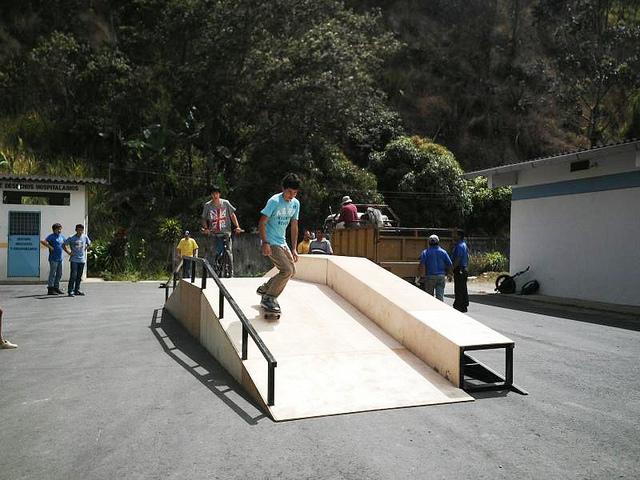What is the boy on the ramp doing?
Quick response, please. Skateboarding. What is the 2nd boy riding?
Keep it brief. Bike. Which foot is on the front of the skateboard?
Quick response, please. Right. How many humanoid statues are present in the photo?
Write a very short answer. 0. How many guys are on top the ramp?
Quick response, please. 2. 